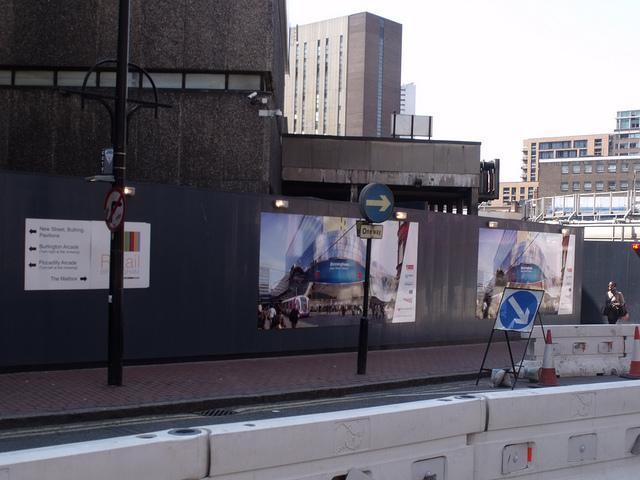What are the blue signs being used for?

Choices:
A) decoration
B) advertising
C) selling
D) directing traffic directing traffic 